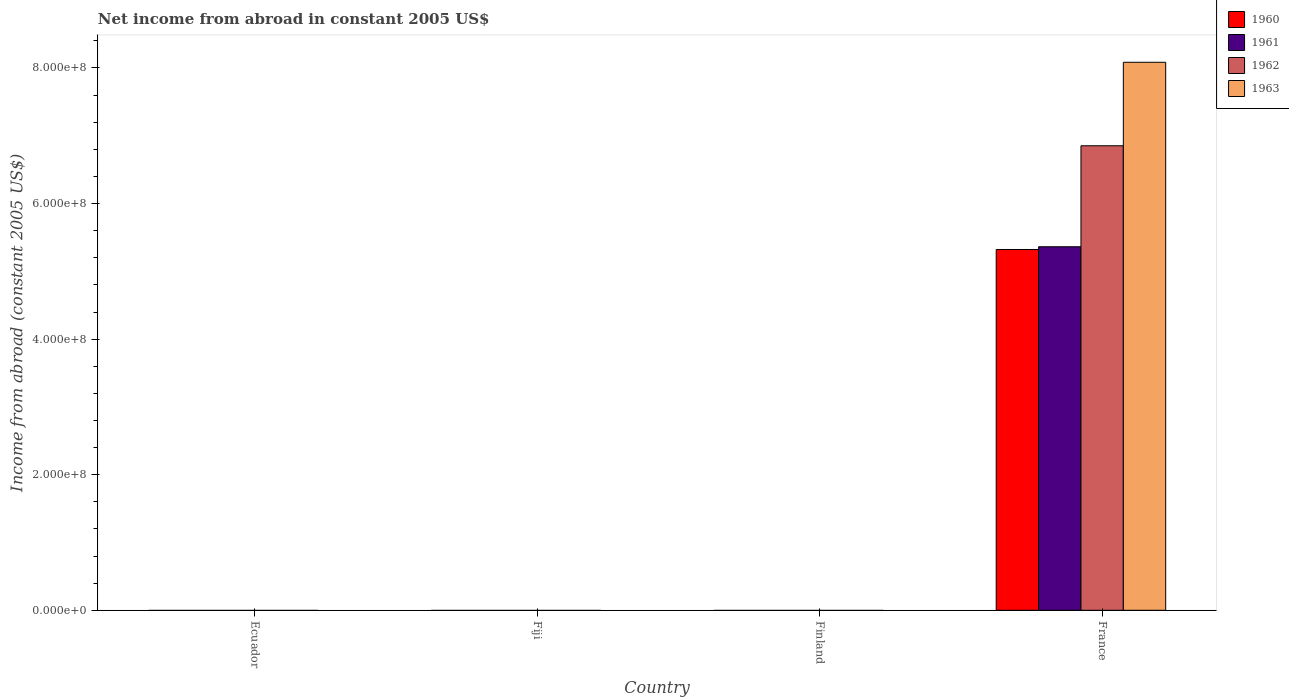How many different coloured bars are there?
Your response must be concise. 4. Are the number of bars on each tick of the X-axis equal?
Provide a succinct answer. No. What is the label of the 3rd group of bars from the left?
Provide a short and direct response. Finland. In how many cases, is the number of bars for a given country not equal to the number of legend labels?
Give a very brief answer. 3. What is the net income from abroad in 1960 in Fiji?
Your answer should be very brief. 0. Across all countries, what is the maximum net income from abroad in 1961?
Your answer should be compact. 5.36e+08. Across all countries, what is the minimum net income from abroad in 1962?
Make the answer very short. 0. What is the total net income from abroad in 1960 in the graph?
Ensure brevity in your answer.  5.32e+08. What is the difference between the net income from abroad in 1960 in Finland and the net income from abroad in 1963 in Ecuador?
Your answer should be very brief. 0. What is the average net income from abroad in 1961 per country?
Your answer should be very brief. 1.34e+08. What is the difference between the net income from abroad of/in 1960 and net income from abroad of/in 1963 in France?
Offer a very short reply. -2.76e+08. What is the difference between the highest and the lowest net income from abroad in 1962?
Make the answer very short. 6.85e+08. Are all the bars in the graph horizontal?
Your answer should be compact. No. What is the difference between two consecutive major ticks on the Y-axis?
Give a very brief answer. 2.00e+08. Are the values on the major ticks of Y-axis written in scientific E-notation?
Give a very brief answer. Yes. Does the graph contain grids?
Your response must be concise. No. Where does the legend appear in the graph?
Your response must be concise. Top right. How are the legend labels stacked?
Give a very brief answer. Vertical. What is the title of the graph?
Give a very brief answer. Net income from abroad in constant 2005 US$. Does "1999" appear as one of the legend labels in the graph?
Keep it short and to the point. No. What is the label or title of the X-axis?
Provide a short and direct response. Country. What is the label or title of the Y-axis?
Provide a short and direct response. Income from abroad (constant 2005 US$). What is the Income from abroad (constant 2005 US$) in 1961 in Ecuador?
Make the answer very short. 0. What is the Income from abroad (constant 2005 US$) in 1962 in Ecuador?
Provide a short and direct response. 0. What is the Income from abroad (constant 2005 US$) in 1963 in Ecuador?
Offer a terse response. 0. What is the Income from abroad (constant 2005 US$) of 1960 in Fiji?
Keep it short and to the point. 0. What is the Income from abroad (constant 2005 US$) in 1961 in Fiji?
Your answer should be very brief. 0. What is the Income from abroad (constant 2005 US$) of 1962 in Fiji?
Your answer should be very brief. 0. What is the Income from abroad (constant 2005 US$) in 1963 in Fiji?
Offer a terse response. 0. What is the Income from abroad (constant 2005 US$) in 1962 in Finland?
Your response must be concise. 0. What is the Income from abroad (constant 2005 US$) of 1960 in France?
Offer a terse response. 5.32e+08. What is the Income from abroad (constant 2005 US$) of 1961 in France?
Offer a very short reply. 5.36e+08. What is the Income from abroad (constant 2005 US$) of 1962 in France?
Offer a very short reply. 6.85e+08. What is the Income from abroad (constant 2005 US$) in 1963 in France?
Make the answer very short. 8.08e+08. Across all countries, what is the maximum Income from abroad (constant 2005 US$) in 1960?
Your answer should be very brief. 5.32e+08. Across all countries, what is the maximum Income from abroad (constant 2005 US$) in 1961?
Ensure brevity in your answer.  5.36e+08. Across all countries, what is the maximum Income from abroad (constant 2005 US$) of 1962?
Provide a succinct answer. 6.85e+08. Across all countries, what is the maximum Income from abroad (constant 2005 US$) in 1963?
Give a very brief answer. 8.08e+08. Across all countries, what is the minimum Income from abroad (constant 2005 US$) in 1960?
Offer a terse response. 0. Across all countries, what is the minimum Income from abroad (constant 2005 US$) of 1963?
Give a very brief answer. 0. What is the total Income from abroad (constant 2005 US$) in 1960 in the graph?
Provide a short and direct response. 5.32e+08. What is the total Income from abroad (constant 2005 US$) in 1961 in the graph?
Offer a very short reply. 5.36e+08. What is the total Income from abroad (constant 2005 US$) in 1962 in the graph?
Ensure brevity in your answer.  6.85e+08. What is the total Income from abroad (constant 2005 US$) in 1963 in the graph?
Provide a succinct answer. 8.08e+08. What is the average Income from abroad (constant 2005 US$) of 1960 per country?
Your response must be concise. 1.33e+08. What is the average Income from abroad (constant 2005 US$) of 1961 per country?
Offer a very short reply. 1.34e+08. What is the average Income from abroad (constant 2005 US$) in 1962 per country?
Provide a short and direct response. 1.71e+08. What is the average Income from abroad (constant 2005 US$) in 1963 per country?
Keep it short and to the point. 2.02e+08. What is the difference between the Income from abroad (constant 2005 US$) of 1960 and Income from abroad (constant 2005 US$) of 1961 in France?
Give a very brief answer. -4.05e+06. What is the difference between the Income from abroad (constant 2005 US$) in 1960 and Income from abroad (constant 2005 US$) in 1962 in France?
Keep it short and to the point. -1.53e+08. What is the difference between the Income from abroad (constant 2005 US$) of 1960 and Income from abroad (constant 2005 US$) of 1963 in France?
Provide a succinct answer. -2.76e+08. What is the difference between the Income from abroad (constant 2005 US$) of 1961 and Income from abroad (constant 2005 US$) of 1962 in France?
Your answer should be compact. -1.49e+08. What is the difference between the Income from abroad (constant 2005 US$) in 1961 and Income from abroad (constant 2005 US$) in 1963 in France?
Offer a very short reply. -2.72e+08. What is the difference between the Income from abroad (constant 2005 US$) of 1962 and Income from abroad (constant 2005 US$) of 1963 in France?
Provide a succinct answer. -1.23e+08. What is the difference between the highest and the lowest Income from abroad (constant 2005 US$) of 1960?
Give a very brief answer. 5.32e+08. What is the difference between the highest and the lowest Income from abroad (constant 2005 US$) of 1961?
Give a very brief answer. 5.36e+08. What is the difference between the highest and the lowest Income from abroad (constant 2005 US$) in 1962?
Your answer should be compact. 6.85e+08. What is the difference between the highest and the lowest Income from abroad (constant 2005 US$) of 1963?
Keep it short and to the point. 8.08e+08. 